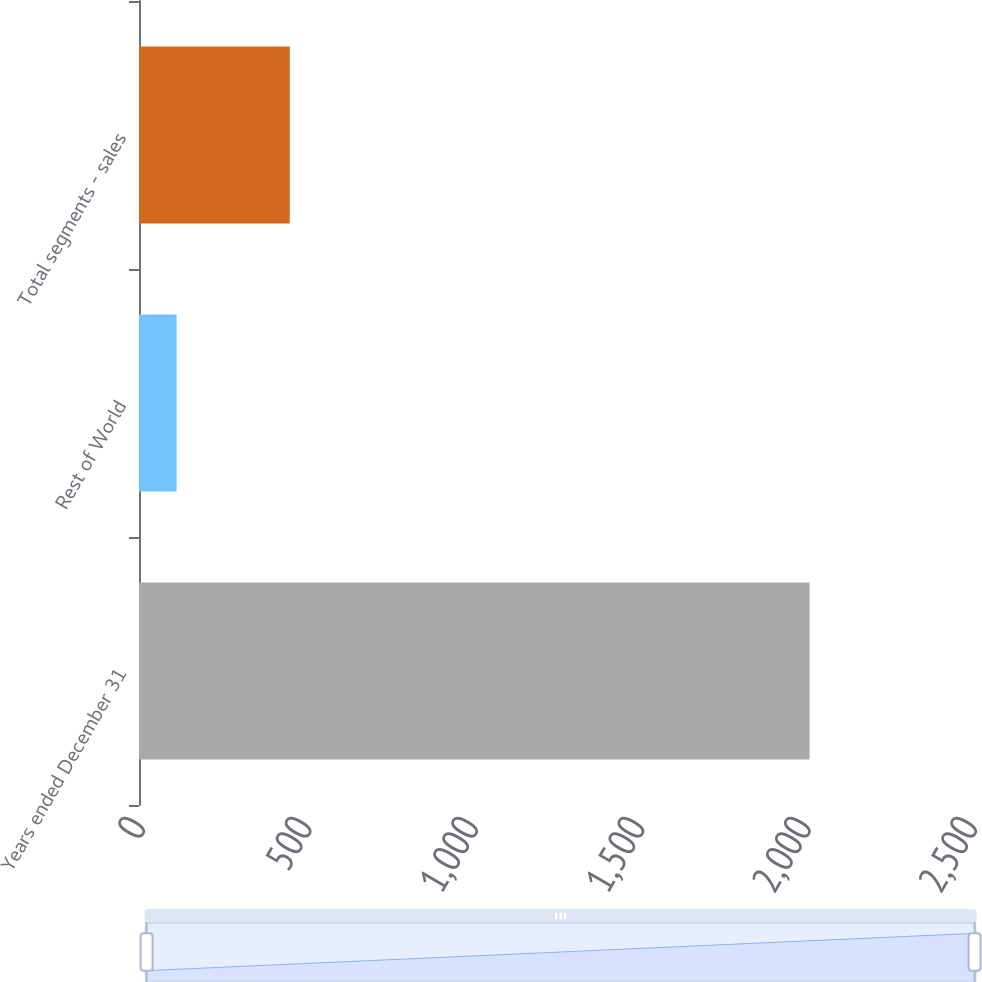Convert chart. <chart><loc_0><loc_0><loc_500><loc_500><bar_chart><fcel>Years ended December 31<fcel>Rest of World<fcel>Total segments - sales<nl><fcel>2015<fcel>113<fcel>452.9<nl></chart> 